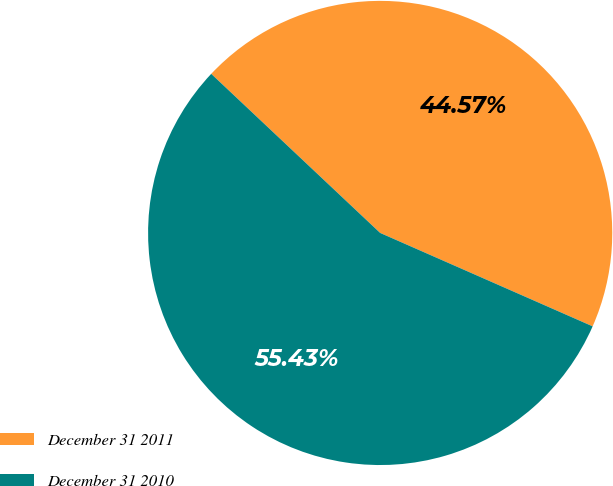Convert chart to OTSL. <chart><loc_0><loc_0><loc_500><loc_500><pie_chart><fcel>December 31 2011<fcel>December 31 2010<nl><fcel>44.57%<fcel>55.43%<nl></chart> 